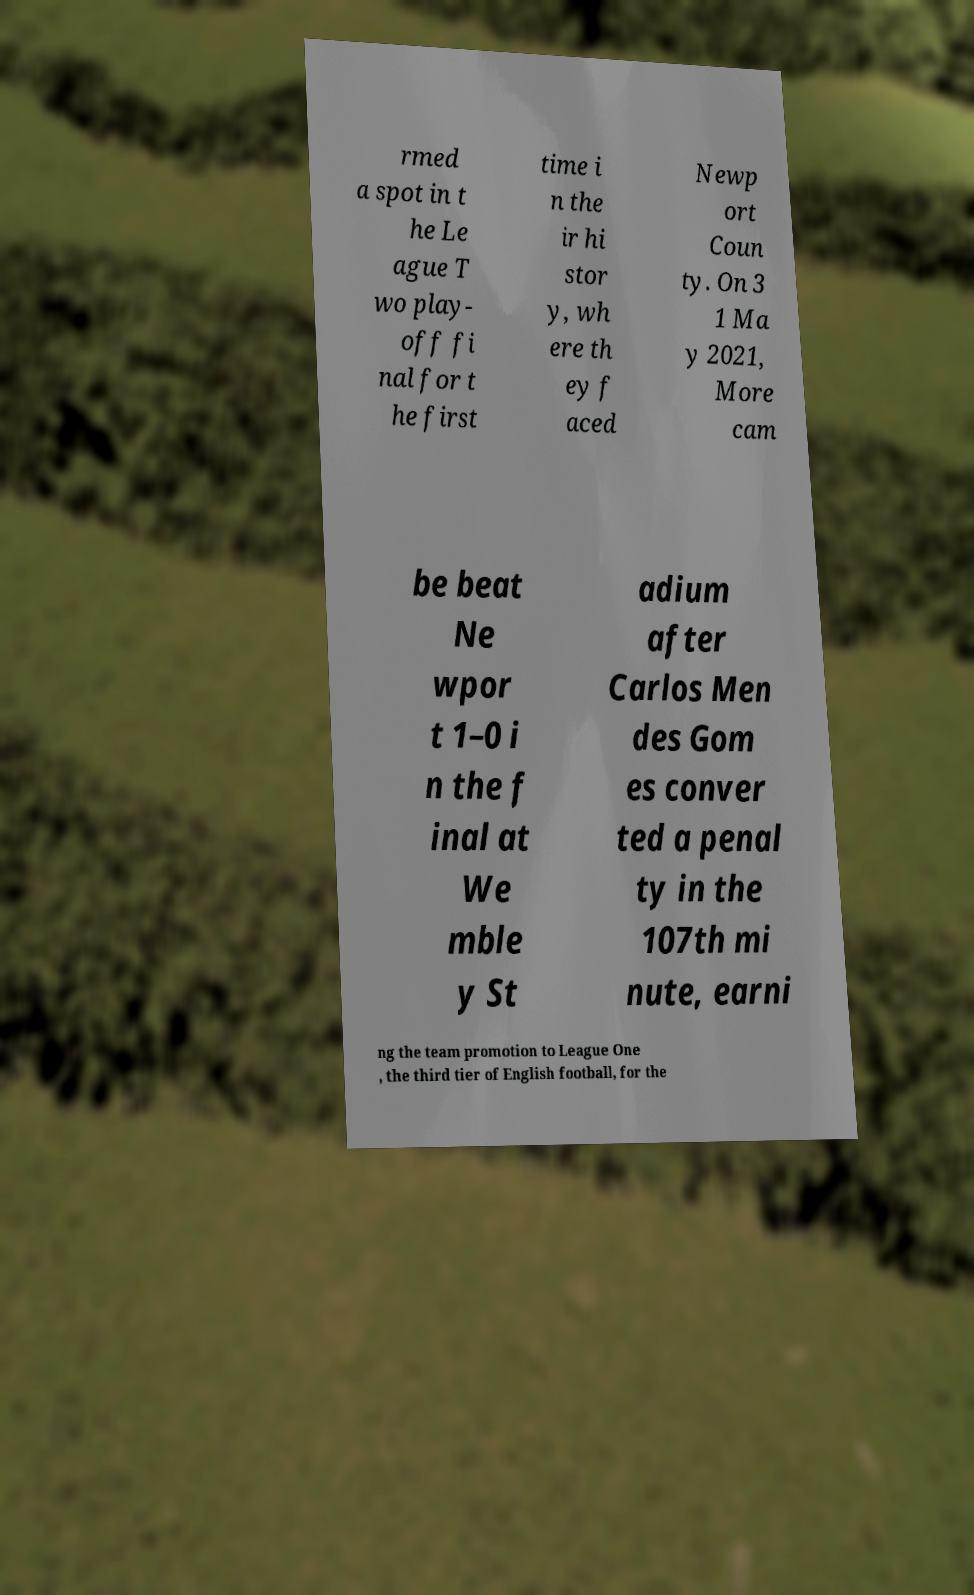Please identify and transcribe the text found in this image. rmed a spot in t he Le ague T wo play- off fi nal for t he first time i n the ir hi stor y, wh ere th ey f aced Newp ort Coun ty. On 3 1 Ma y 2021, More cam be beat Ne wpor t 1–0 i n the f inal at We mble y St adium after Carlos Men des Gom es conver ted a penal ty in the 107th mi nute, earni ng the team promotion to League One , the third tier of English football, for the 